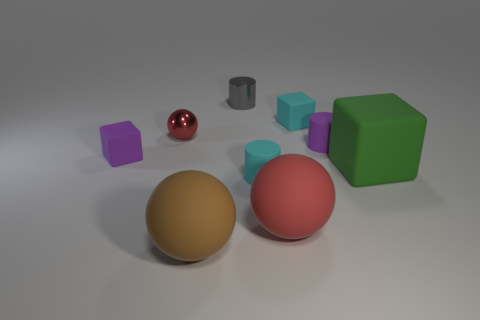Subtract all cyan rubber cylinders. How many cylinders are left? 2 Subtract all brown spheres. How many spheres are left? 2 Subtract all cylinders. How many objects are left? 6 Subtract all purple cylinders. How many cyan cubes are left? 1 Subtract all green matte blocks. Subtract all large brown matte balls. How many objects are left? 7 Add 8 red metal objects. How many red metal objects are left? 9 Add 2 tiny gray cylinders. How many tiny gray cylinders exist? 3 Subtract 1 purple cylinders. How many objects are left? 8 Subtract 1 cylinders. How many cylinders are left? 2 Subtract all yellow blocks. Subtract all yellow cylinders. How many blocks are left? 3 